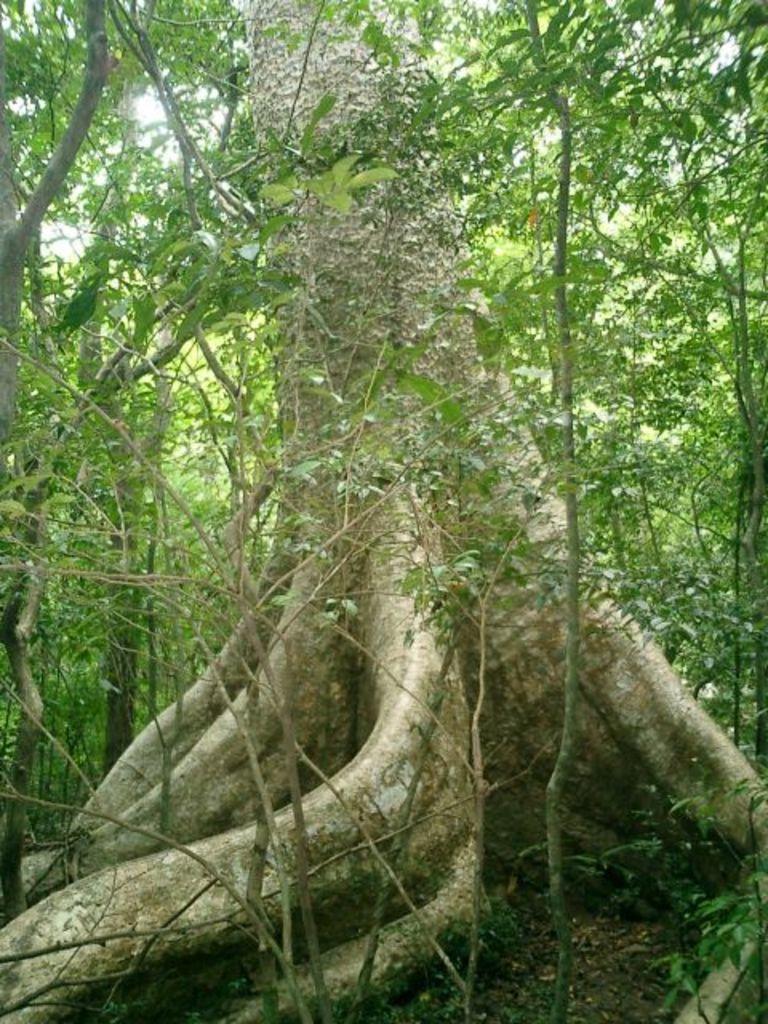Please provide a concise description of this image. In the middle of the picture, we see the stem of the tree and there are many trees in the background. This picture might be clicked in the forest. 